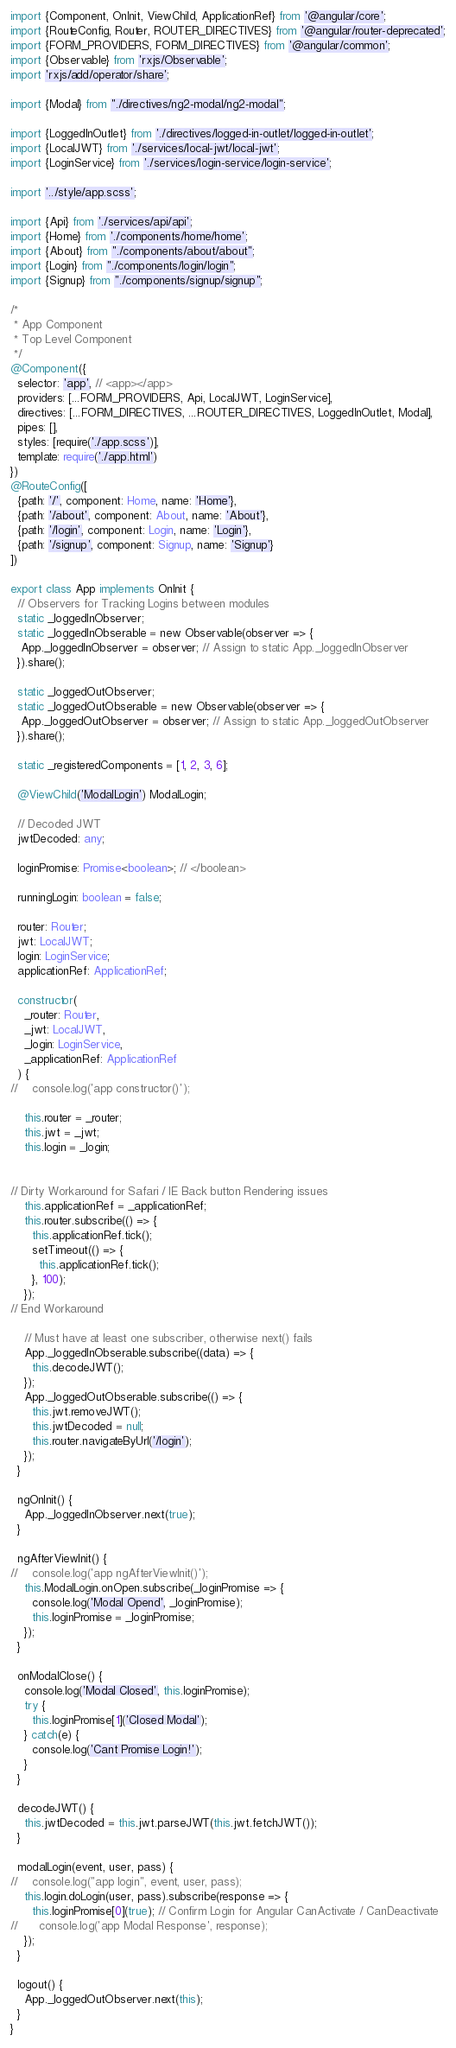Convert code to text. <code><loc_0><loc_0><loc_500><loc_500><_TypeScript_>import {Component, OnInit, ViewChild, ApplicationRef} from '@angular/core';
import {RouteConfig, Router, ROUTER_DIRECTIVES} from '@angular/router-deprecated';
import {FORM_PROVIDERS, FORM_DIRECTIVES} from '@angular/common';
import {Observable} from 'rxjs/Observable';
import 'rxjs/add/operator/share';

import {Modal} from "./directives/ng2-modal/ng2-modal";

import {LoggedInOutlet} from './directives/logged-in-outlet/logged-in-outlet';
import {LocalJWT} from './services/local-jwt/local-jwt';
import {LoginService} from './services/login-service/login-service';

import '../style/app.scss';

import {Api} from './services/api/api';
import {Home} from './components/home/home';
import {About} from "./components/about/about";
import {Login} from "./components/login/login";
import {Signup} from "./components/signup/signup";

/*
 * App Component
 * Top Level Component
 */
@Component({
  selector: 'app', // <app></app>
  providers: [...FORM_PROVIDERS, Api, LocalJWT, LoginService],
  directives: [...FORM_DIRECTIVES, ...ROUTER_DIRECTIVES, LoggedInOutlet, Modal],
  pipes: [],
  styles: [require('./app.scss')],
  template: require('./app.html')
})
@RouteConfig([
  {path: '/', component: Home, name: 'Home'},
  {path: '/about', component: About, name: 'About'},
  {path: '/login', component: Login, name: 'Login'},
  {path: '/signup', component: Signup, name: 'Signup'}
])

export class App implements OnInit {
  // Observers for Tracking Logins between modules
  static _loggedInObserver;
  static _loggedInObserable = new Observable(observer => {
   App._loggedInObserver = observer; // Assign to static App._loggedInObserver
  }).share();

  static _loggedOutObserver;
  static _loggedOutObserable = new Observable(observer => {
   App._loggedOutObserver = observer; // Assign to static App._loggedOutObserver
  }).share();

  static _registeredComponents = [1, 2, 3, 6];

  @ViewChild('ModalLogin') ModalLogin;

  // Decoded JWT
  jwtDecoded: any;

  loginPromise: Promise<boolean>; // </boolean>

  runningLogin: boolean = false;

  router: Router;
  jwt: LocalJWT;
  login: LoginService;
  applicationRef: ApplicationRef;

  constructor(
    _router: Router,
    _jwt: LocalJWT,
    _login: LoginService,
    _applicationRef: ApplicationRef
  ) {
//    console.log('app constructor()');

    this.router = _router;
    this.jwt = _jwt;
    this.login = _login;


// Dirty Workaround for Safari / IE Back button Rendering issues
    this.applicationRef = _applicationRef;
    this.router.subscribe(() => {
      this.applicationRef.tick();
      setTimeout(() => {
        this.applicationRef.tick();
      }, 100);
    });
// End Workaround

    // Must have at least one subscriber, otherwise next() fails
    App._loggedInObserable.subscribe((data) => {
      this.decodeJWT();
    });
    App._loggedOutObserable.subscribe(() => {
      this.jwt.removeJWT();
      this.jwtDecoded = null;
      this.router.navigateByUrl('/login');
    });
  }

  ngOnInit() {
    App._loggedInObserver.next(true);
  }

  ngAfterViewInit() {
//    console.log('app ngAfterViewInit()');
    this.ModalLogin.onOpen.subscribe(_loginPromise => {
      console.log('Modal Opend', _loginPromise);
      this.loginPromise = _loginPromise;
    });
  }

  onModalClose() {
    console.log('Modal Closed', this.loginPromise);
    try {
      this.loginPromise[1]('Closed Modal');
    } catch(e) {
      console.log('Cant Promise Login!');
    }
  }

  decodeJWT() {
    this.jwtDecoded = this.jwt.parseJWT(this.jwt.fetchJWT());
  }

  modalLogin(event, user, pass) {
//    console.log("app login", event, user, pass);
    this.login.doLogin(user, pass).subscribe(response => {
      this.loginPromise[0](true); // Confirm Login for Angular CanActivate / CanDeactivate
//      console.log('app Modal Response', response);
    });
  }

  logout() {
    App._loggedOutObserver.next(this);
  }
}
</code> 